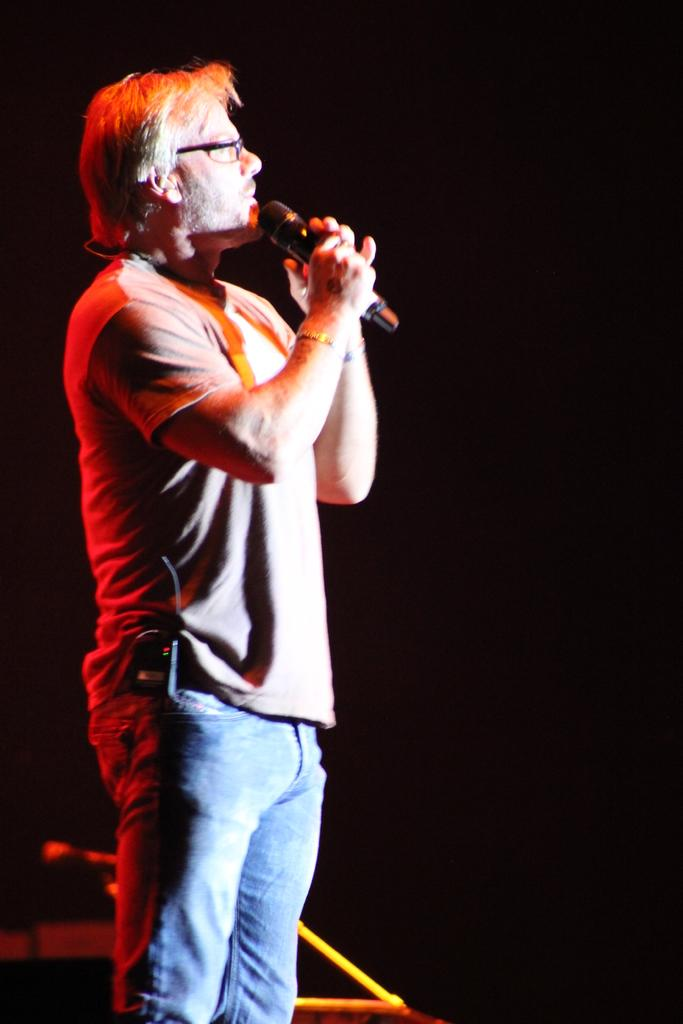What is the main subject of the picture? The main subject of the picture is a man. What is the man doing in the picture? The man is standing in the picture. What object is the man holding in the picture? The man is holding a microphone in the picture. Can you describe the background of the picture? The backdrop of the picture is dark. What type of food is the man eating in the picture? There is no food present in the image, and the man is not eating anything. Can you see any yams or twigs in the picture? No, there are no yams or twigs present in the image. 